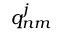<formula> <loc_0><loc_0><loc_500><loc_500>q _ { n m } ^ { j }</formula> 